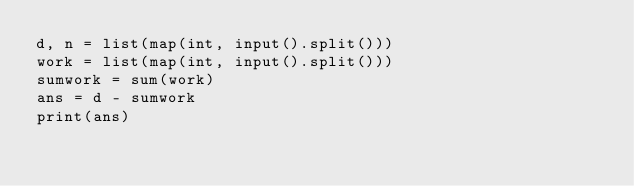<code> <loc_0><loc_0><loc_500><loc_500><_Python_>d, n = list(map(int, input().split()))
work = list(map(int, input().split()))
sumwork = sum(work)
ans = d - sumwork
print(ans)</code> 